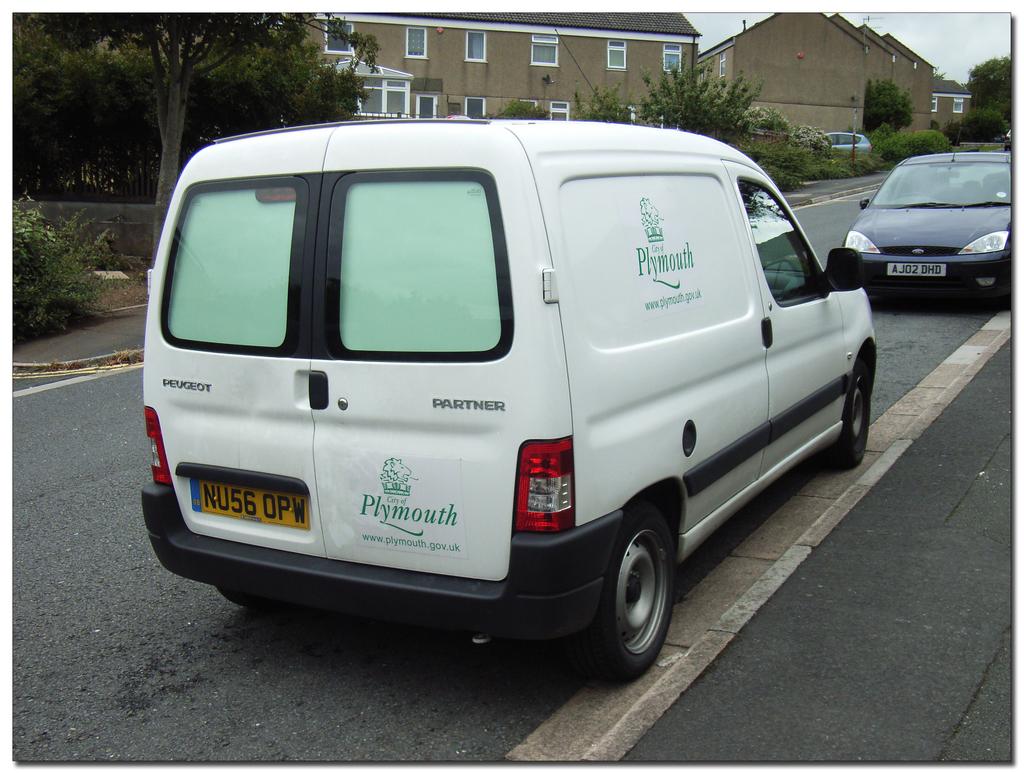What city's name is written in green on the van?
Your answer should be compact. Plymouth. 